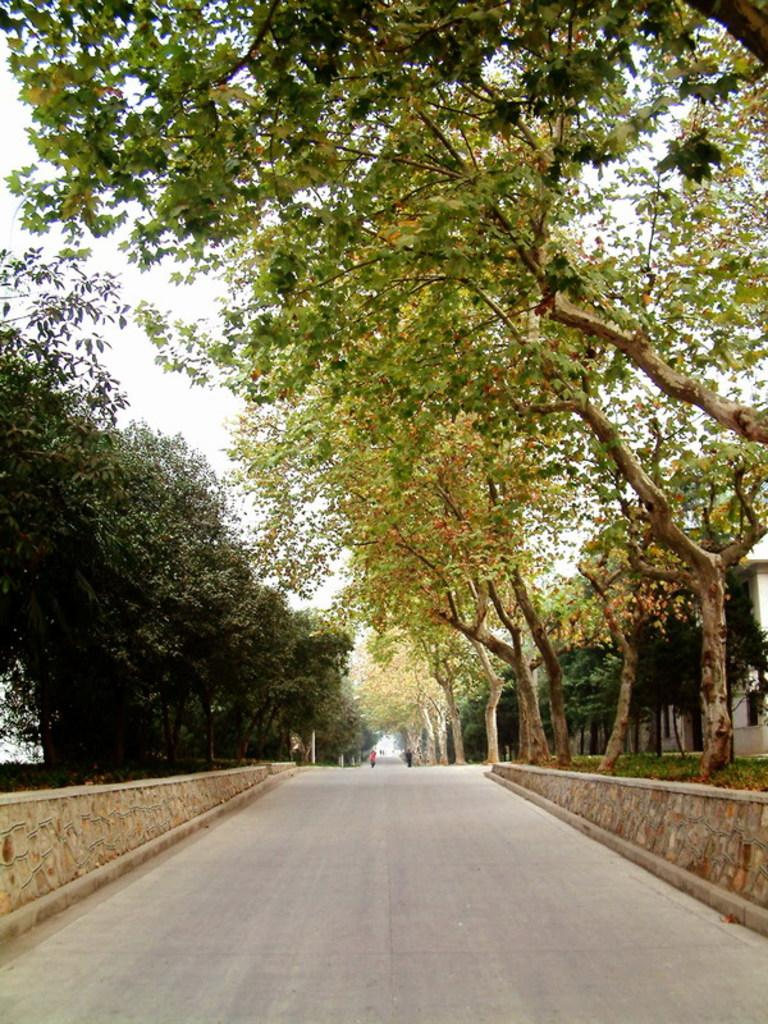What is the main feature in the center of the image? There is a road in the center of the image. Can you describe the people in the image? There are people in the image, but their specific actions or appearances are not mentioned in the facts. What can be seen in the background of the image? There are buildings, trees, and the sky visible in the background of the image. What type of bubble is floating above the road in the image? There is no bubble present in the image; it only features a road, people, buildings, trees, and the sky. 